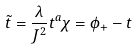<formula> <loc_0><loc_0><loc_500><loc_500>\tilde { t } = \frac { \lambda } { J ^ { 2 } } t ^ { a } \chi = \phi _ { + } - t</formula> 